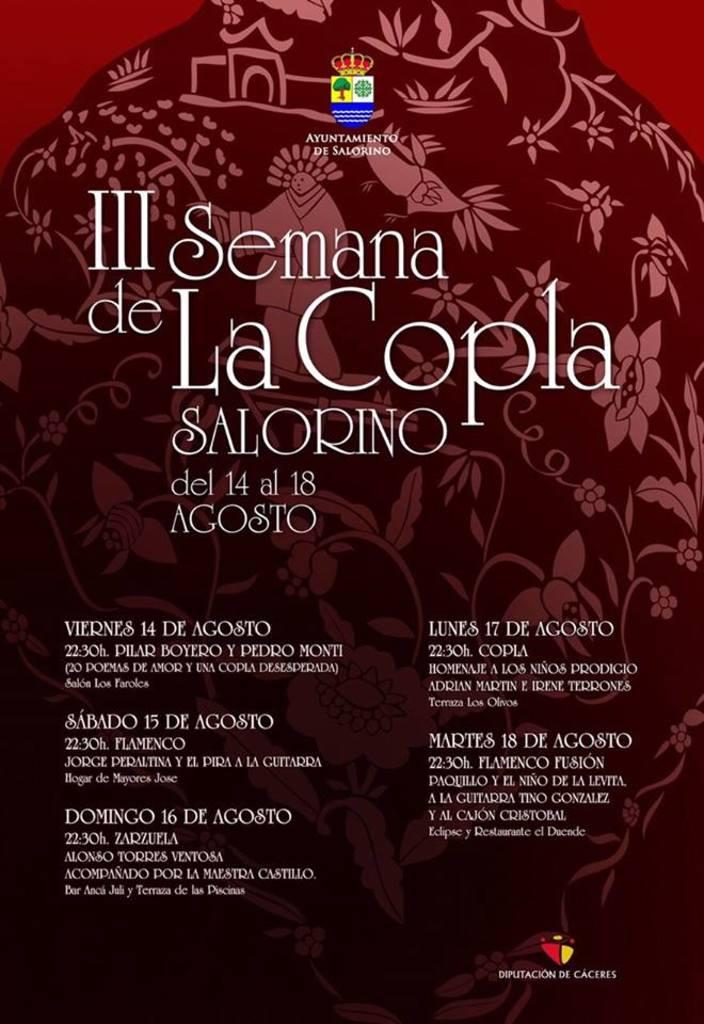<image>
Give a short and clear explanation of the subsequent image. A Spanish language advertisement for III Semana de La Copla SALORINO including the dates and times of events. 